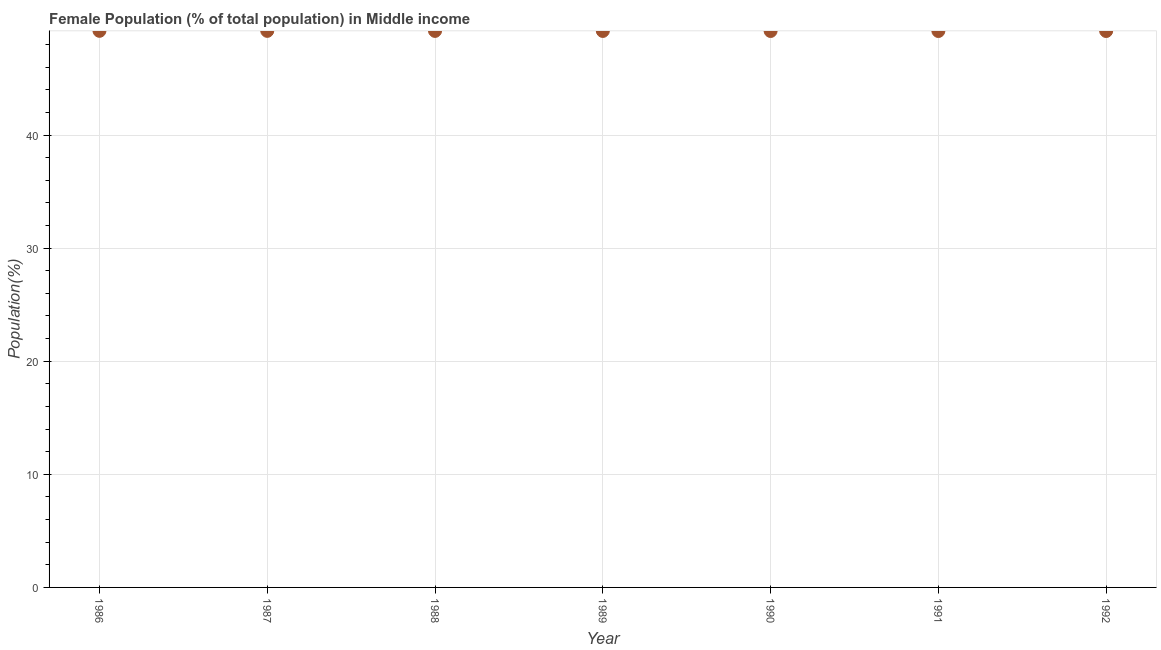What is the female population in 1986?
Offer a terse response. 49.21. Across all years, what is the maximum female population?
Your answer should be compact. 49.21. Across all years, what is the minimum female population?
Give a very brief answer. 49.19. What is the sum of the female population?
Make the answer very short. 344.4. What is the difference between the female population in 1987 and 1991?
Keep it short and to the point. 0.01. What is the average female population per year?
Offer a terse response. 49.2. What is the median female population?
Give a very brief answer. 49.2. What is the ratio of the female population in 1986 to that in 1992?
Provide a short and direct response. 1. Is the difference between the female population in 1986 and 1990 greater than the difference between any two years?
Ensure brevity in your answer.  No. What is the difference between the highest and the second highest female population?
Offer a very short reply. 0. What is the difference between the highest and the lowest female population?
Keep it short and to the point. 0.02. Does the female population monotonically increase over the years?
Keep it short and to the point. No. How many years are there in the graph?
Your answer should be very brief. 7. Does the graph contain any zero values?
Ensure brevity in your answer.  No. What is the title of the graph?
Your answer should be compact. Female Population (% of total population) in Middle income. What is the label or title of the X-axis?
Keep it short and to the point. Year. What is the label or title of the Y-axis?
Your response must be concise. Population(%). What is the Population(%) in 1986?
Your answer should be very brief. 49.21. What is the Population(%) in 1987?
Your answer should be very brief. 49.21. What is the Population(%) in 1988?
Make the answer very short. 49.2. What is the Population(%) in 1989?
Offer a terse response. 49.2. What is the Population(%) in 1990?
Your answer should be very brief. 49.2. What is the Population(%) in 1991?
Offer a very short reply. 49.19. What is the Population(%) in 1992?
Keep it short and to the point. 49.19. What is the difference between the Population(%) in 1986 and 1987?
Your answer should be very brief. 0. What is the difference between the Population(%) in 1986 and 1988?
Ensure brevity in your answer.  0.01. What is the difference between the Population(%) in 1986 and 1989?
Your answer should be compact. 0.01. What is the difference between the Population(%) in 1986 and 1990?
Your response must be concise. 0.01. What is the difference between the Population(%) in 1986 and 1991?
Give a very brief answer. 0.02. What is the difference between the Population(%) in 1986 and 1992?
Your answer should be very brief. 0.02. What is the difference between the Population(%) in 1987 and 1988?
Provide a short and direct response. 0. What is the difference between the Population(%) in 1987 and 1989?
Keep it short and to the point. 0.01. What is the difference between the Population(%) in 1987 and 1990?
Keep it short and to the point. 0.01. What is the difference between the Population(%) in 1987 and 1991?
Keep it short and to the point. 0.01. What is the difference between the Population(%) in 1987 and 1992?
Keep it short and to the point. 0.01. What is the difference between the Population(%) in 1988 and 1989?
Offer a terse response. 0. What is the difference between the Population(%) in 1988 and 1990?
Your response must be concise. 0.01. What is the difference between the Population(%) in 1988 and 1991?
Make the answer very short. 0.01. What is the difference between the Population(%) in 1988 and 1992?
Keep it short and to the point. 0.01. What is the difference between the Population(%) in 1989 and 1990?
Your answer should be compact. 0. What is the difference between the Population(%) in 1989 and 1991?
Make the answer very short. 0. What is the difference between the Population(%) in 1989 and 1992?
Give a very brief answer. 0. What is the difference between the Population(%) in 1990 and 1991?
Make the answer very short. 0. What is the difference between the Population(%) in 1990 and 1992?
Give a very brief answer. 0. What is the difference between the Population(%) in 1991 and 1992?
Give a very brief answer. 0. What is the ratio of the Population(%) in 1986 to that in 1992?
Provide a short and direct response. 1. What is the ratio of the Population(%) in 1987 to that in 1988?
Your answer should be very brief. 1. What is the ratio of the Population(%) in 1987 to that in 1991?
Offer a very short reply. 1. What is the ratio of the Population(%) in 1988 to that in 1990?
Your answer should be compact. 1. What is the ratio of the Population(%) in 1988 to that in 1991?
Keep it short and to the point. 1. What is the ratio of the Population(%) in 1989 to that in 1992?
Ensure brevity in your answer.  1. What is the ratio of the Population(%) in 1990 to that in 1991?
Offer a very short reply. 1. 